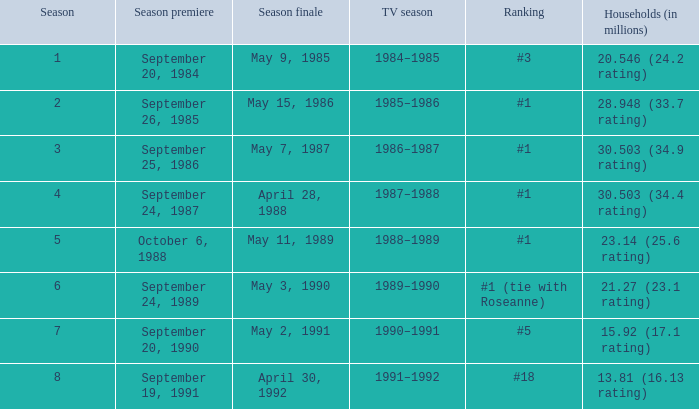Which season of a tv show has a viewership of 30.503 million households and a 34.9 rating? 1986–1987. 